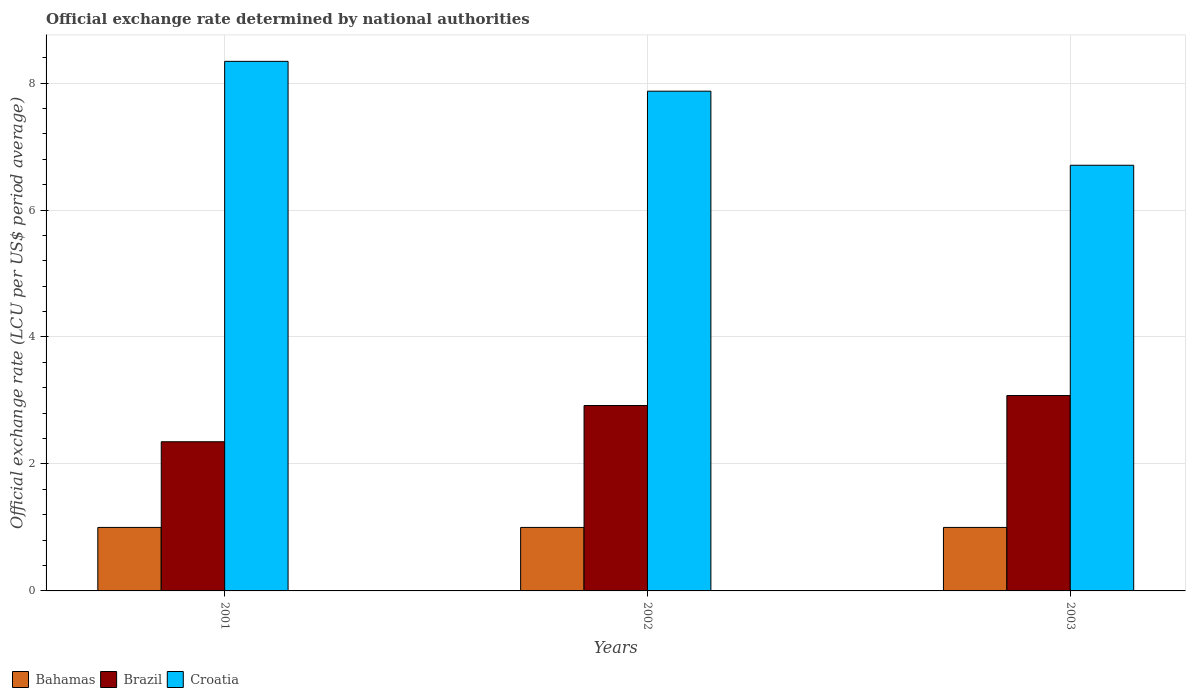How many different coloured bars are there?
Ensure brevity in your answer.  3. Are the number of bars per tick equal to the number of legend labels?
Offer a very short reply. Yes. Are the number of bars on each tick of the X-axis equal?
Ensure brevity in your answer.  Yes. How many bars are there on the 1st tick from the left?
Offer a terse response. 3. How many bars are there on the 3rd tick from the right?
Provide a short and direct response. 3. In how many cases, is the number of bars for a given year not equal to the number of legend labels?
Your answer should be compact. 0. What is the official exchange rate in Brazil in 2003?
Ensure brevity in your answer.  3.08. Across all years, what is the maximum official exchange rate in Brazil?
Give a very brief answer. 3.08. What is the total official exchange rate in Croatia in the graph?
Give a very brief answer. 22.92. What is the difference between the official exchange rate in Croatia in 2001 and that in 2002?
Give a very brief answer. 0.47. What is the difference between the official exchange rate in Bahamas in 2003 and the official exchange rate in Croatia in 2002?
Provide a short and direct response. -6.87. What is the average official exchange rate in Brazil per year?
Provide a succinct answer. 2.78. In the year 2001, what is the difference between the official exchange rate in Brazil and official exchange rate in Bahamas?
Provide a short and direct response. 1.35. In how many years, is the official exchange rate in Croatia greater than 0.4 LCU?
Your response must be concise. 3. What is the ratio of the official exchange rate in Brazil in 2001 to that in 2002?
Ensure brevity in your answer.  0.8. Is the difference between the official exchange rate in Brazil in 2001 and 2002 greater than the difference between the official exchange rate in Bahamas in 2001 and 2002?
Your answer should be very brief. No. What is the difference between the highest and the second highest official exchange rate in Croatia?
Ensure brevity in your answer.  0.47. What is the difference between the highest and the lowest official exchange rate in Brazil?
Your answer should be compact. 0.73. In how many years, is the official exchange rate in Brazil greater than the average official exchange rate in Brazil taken over all years?
Offer a very short reply. 2. What does the 1st bar from the left in 2002 represents?
Keep it short and to the point. Bahamas. Is it the case that in every year, the sum of the official exchange rate in Bahamas and official exchange rate in Croatia is greater than the official exchange rate in Brazil?
Your answer should be compact. Yes. How many bars are there?
Offer a terse response. 9. How many years are there in the graph?
Keep it short and to the point. 3. How many legend labels are there?
Provide a succinct answer. 3. What is the title of the graph?
Keep it short and to the point. Official exchange rate determined by national authorities. What is the label or title of the Y-axis?
Give a very brief answer. Official exchange rate (LCU per US$ period average). What is the Official exchange rate (LCU per US$ period average) of Brazil in 2001?
Keep it short and to the point. 2.35. What is the Official exchange rate (LCU per US$ period average) of Croatia in 2001?
Your response must be concise. 8.34. What is the Official exchange rate (LCU per US$ period average) of Bahamas in 2002?
Offer a terse response. 1. What is the Official exchange rate (LCU per US$ period average) of Brazil in 2002?
Offer a very short reply. 2.92. What is the Official exchange rate (LCU per US$ period average) of Croatia in 2002?
Offer a very short reply. 7.87. What is the Official exchange rate (LCU per US$ period average) of Bahamas in 2003?
Offer a terse response. 1. What is the Official exchange rate (LCU per US$ period average) of Brazil in 2003?
Provide a short and direct response. 3.08. What is the Official exchange rate (LCU per US$ period average) in Croatia in 2003?
Provide a short and direct response. 6.7. Across all years, what is the maximum Official exchange rate (LCU per US$ period average) in Bahamas?
Provide a succinct answer. 1. Across all years, what is the maximum Official exchange rate (LCU per US$ period average) of Brazil?
Give a very brief answer. 3.08. Across all years, what is the maximum Official exchange rate (LCU per US$ period average) in Croatia?
Provide a succinct answer. 8.34. Across all years, what is the minimum Official exchange rate (LCU per US$ period average) of Bahamas?
Ensure brevity in your answer.  1. Across all years, what is the minimum Official exchange rate (LCU per US$ period average) of Brazil?
Give a very brief answer. 2.35. Across all years, what is the minimum Official exchange rate (LCU per US$ period average) of Croatia?
Make the answer very short. 6.7. What is the total Official exchange rate (LCU per US$ period average) in Bahamas in the graph?
Offer a terse response. 3. What is the total Official exchange rate (LCU per US$ period average) in Brazil in the graph?
Give a very brief answer. 8.35. What is the total Official exchange rate (LCU per US$ period average) in Croatia in the graph?
Offer a terse response. 22.92. What is the difference between the Official exchange rate (LCU per US$ period average) in Bahamas in 2001 and that in 2002?
Offer a terse response. 0. What is the difference between the Official exchange rate (LCU per US$ period average) of Brazil in 2001 and that in 2002?
Your response must be concise. -0.57. What is the difference between the Official exchange rate (LCU per US$ period average) of Croatia in 2001 and that in 2002?
Offer a terse response. 0.47. What is the difference between the Official exchange rate (LCU per US$ period average) of Brazil in 2001 and that in 2003?
Make the answer very short. -0.73. What is the difference between the Official exchange rate (LCU per US$ period average) of Croatia in 2001 and that in 2003?
Your answer should be compact. 1.64. What is the difference between the Official exchange rate (LCU per US$ period average) in Bahamas in 2002 and that in 2003?
Provide a succinct answer. 0. What is the difference between the Official exchange rate (LCU per US$ period average) of Brazil in 2002 and that in 2003?
Offer a terse response. -0.16. What is the difference between the Official exchange rate (LCU per US$ period average) of Bahamas in 2001 and the Official exchange rate (LCU per US$ period average) of Brazil in 2002?
Offer a terse response. -1.92. What is the difference between the Official exchange rate (LCU per US$ period average) of Bahamas in 2001 and the Official exchange rate (LCU per US$ period average) of Croatia in 2002?
Your answer should be very brief. -6.87. What is the difference between the Official exchange rate (LCU per US$ period average) in Brazil in 2001 and the Official exchange rate (LCU per US$ period average) in Croatia in 2002?
Provide a succinct answer. -5.52. What is the difference between the Official exchange rate (LCU per US$ period average) of Bahamas in 2001 and the Official exchange rate (LCU per US$ period average) of Brazil in 2003?
Your answer should be compact. -2.08. What is the difference between the Official exchange rate (LCU per US$ period average) in Bahamas in 2001 and the Official exchange rate (LCU per US$ period average) in Croatia in 2003?
Your answer should be very brief. -5.71. What is the difference between the Official exchange rate (LCU per US$ period average) in Brazil in 2001 and the Official exchange rate (LCU per US$ period average) in Croatia in 2003?
Make the answer very short. -4.36. What is the difference between the Official exchange rate (LCU per US$ period average) of Bahamas in 2002 and the Official exchange rate (LCU per US$ period average) of Brazil in 2003?
Keep it short and to the point. -2.08. What is the difference between the Official exchange rate (LCU per US$ period average) of Bahamas in 2002 and the Official exchange rate (LCU per US$ period average) of Croatia in 2003?
Your response must be concise. -5.71. What is the difference between the Official exchange rate (LCU per US$ period average) in Brazil in 2002 and the Official exchange rate (LCU per US$ period average) in Croatia in 2003?
Offer a terse response. -3.78. What is the average Official exchange rate (LCU per US$ period average) in Brazil per year?
Your response must be concise. 2.78. What is the average Official exchange rate (LCU per US$ period average) of Croatia per year?
Ensure brevity in your answer.  7.64. In the year 2001, what is the difference between the Official exchange rate (LCU per US$ period average) of Bahamas and Official exchange rate (LCU per US$ period average) of Brazil?
Provide a short and direct response. -1.35. In the year 2001, what is the difference between the Official exchange rate (LCU per US$ period average) in Bahamas and Official exchange rate (LCU per US$ period average) in Croatia?
Ensure brevity in your answer.  -7.34. In the year 2001, what is the difference between the Official exchange rate (LCU per US$ period average) in Brazil and Official exchange rate (LCU per US$ period average) in Croatia?
Your response must be concise. -5.99. In the year 2002, what is the difference between the Official exchange rate (LCU per US$ period average) in Bahamas and Official exchange rate (LCU per US$ period average) in Brazil?
Offer a terse response. -1.92. In the year 2002, what is the difference between the Official exchange rate (LCU per US$ period average) of Bahamas and Official exchange rate (LCU per US$ period average) of Croatia?
Make the answer very short. -6.87. In the year 2002, what is the difference between the Official exchange rate (LCU per US$ period average) of Brazil and Official exchange rate (LCU per US$ period average) of Croatia?
Offer a very short reply. -4.95. In the year 2003, what is the difference between the Official exchange rate (LCU per US$ period average) of Bahamas and Official exchange rate (LCU per US$ period average) of Brazil?
Ensure brevity in your answer.  -2.08. In the year 2003, what is the difference between the Official exchange rate (LCU per US$ period average) in Bahamas and Official exchange rate (LCU per US$ period average) in Croatia?
Ensure brevity in your answer.  -5.71. In the year 2003, what is the difference between the Official exchange rate (LCU per US$ period average) in Brazil and Official exchange rate (LCU per US$ period average) in Croatia?
Your answer should be compact. -3.63. What is the ratio of the Official exchange rate (LCU per US$ period average) in Bahamas in 2001 to that in 2002?
Offer a terse response. 1. What is the ratio of the Official exchange rate (LCU per US$ period average) of Brazil in 2001 to that in 2002?
Ensure brevity in your answer.  0.8. What is the ratio of the Official exchange rate (LCU per US$ period average) of Croatia in 2001 to that in 2002?
Provide a short and direct response. 1.06. What is the ratio of the Official exchange rate (LCU per US$ period average) of Bahamas in 2001 to that in 2003?
Offer a terse response. 1. What is the ratio of the Official exchange rate (LCU per US$ period average) in Brazil in 2001 to that in 2003?
Keep it short and to the point. 0.76. What is the ratio of the Official exchange rate (LCU per US$ period average) in Croatia in 2001 to that in 2003?
Make the answer very short. 1.24. What is the ratio of the Official exchange rate (LCU per US$ period average) of Brazil in 2002 to that in 2003?
Give a very brief answer. 0.95. What is the ratio of the Official exchange rate (LCU per US$ period average) of Croatia in 2002 to that in 2003?
Provide a short and direct response. 1.17. What is the difference between the highest and the second highest Official exchange rate (LCU per US$ period average) of Brazil?
Provide a succinct answer. 0.16. What is the difference between the highest and the second highest Official exchange rate (LCU per US$ period average) of Croatia?
Provide a short and direct response. 0.47. What is the difference between the highest and the lowest Official exchange rate (LCU per US$ period average) in Brazil?
Ensure brevity in your answer.  0.73. What is the difference between the highest and the lowest Official exchange rate (LCU per US$ period average) in Croatia?
Offer a very short reply. 1.64. 